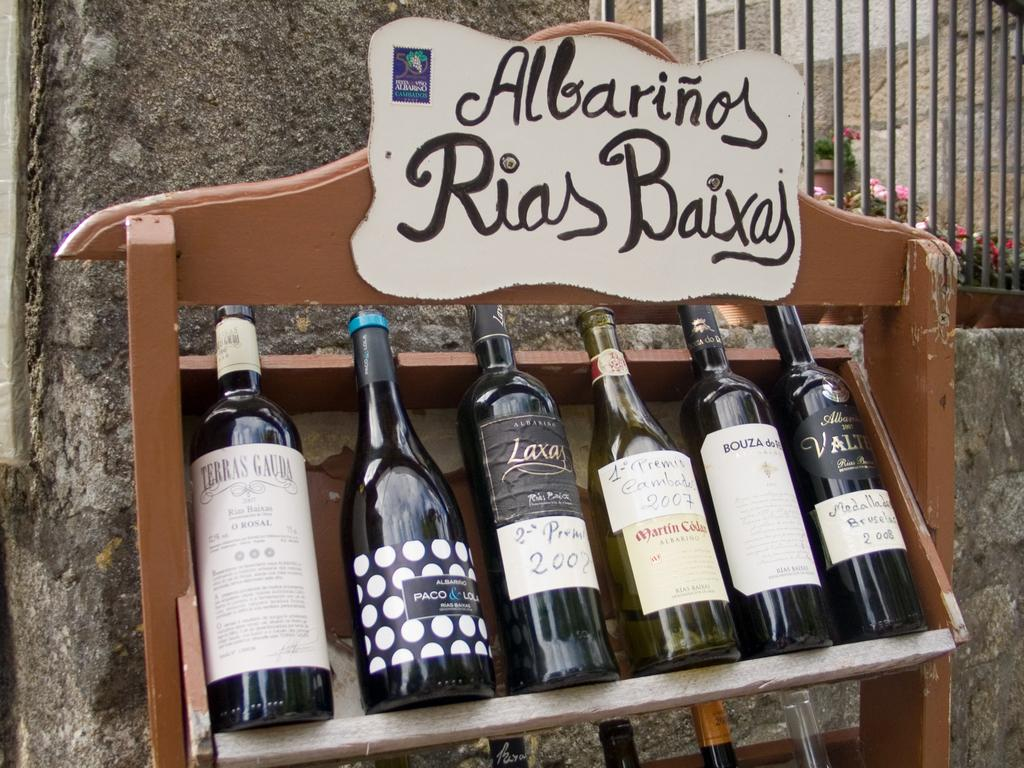<image>
Render a clear and concise summary of the photo. several bottles of wines displayed on a case reading Albarinos Rias Baixas 